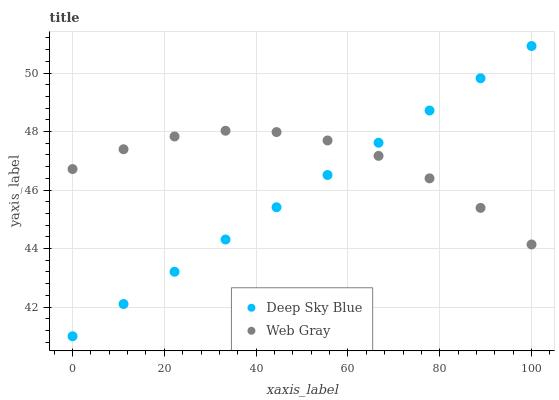Does Deep Sky Blue have the minimum area under the curve?
Answer yes or no. Yes. Does Web Gray have the maximum area under the curve?
Answer yes or no. Yes. Does Deep Sky Blue have the maximum area under the curve?
Answer yes or no. No. Is Deep Sky Blue the smoothest?
Answer yes or no. Yes. Is Web Gray the roughest?
Answer yes or no. Yes. Is Deep Sky Blue the roughest?
Answer yes or no. No. Does Deep Sky Blue have the lowest value?
Answer yes or no. Yes. Does Deep Sky Blue have the highest value?
Answer yes or no. Yes. Does Deep Sky Blue intersect Web Gray?
Answer yes or no. Yes. Is Deep Sky Blue less than Web Gray?
Answer yes or no. No. Is Deep Sky Blue greater than Web Gray?
Answer yes or no. No. 